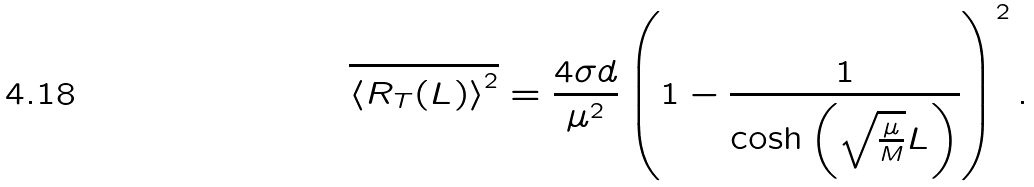<formula> <loc_0><loc_0><loc_500><loc_500>\overline { { \langle } { R } _ { T } ( L ) { \rangle } ^ { 2 } } = \frac { 4 \sigma d } { \mu ^ { 2 } } \left ( 1 - \frac { 1 } { \cosh \left ( \sqrt { \frac { \mu } { M } } L \right ) } \right ) ^ { 2 } .</formula> 